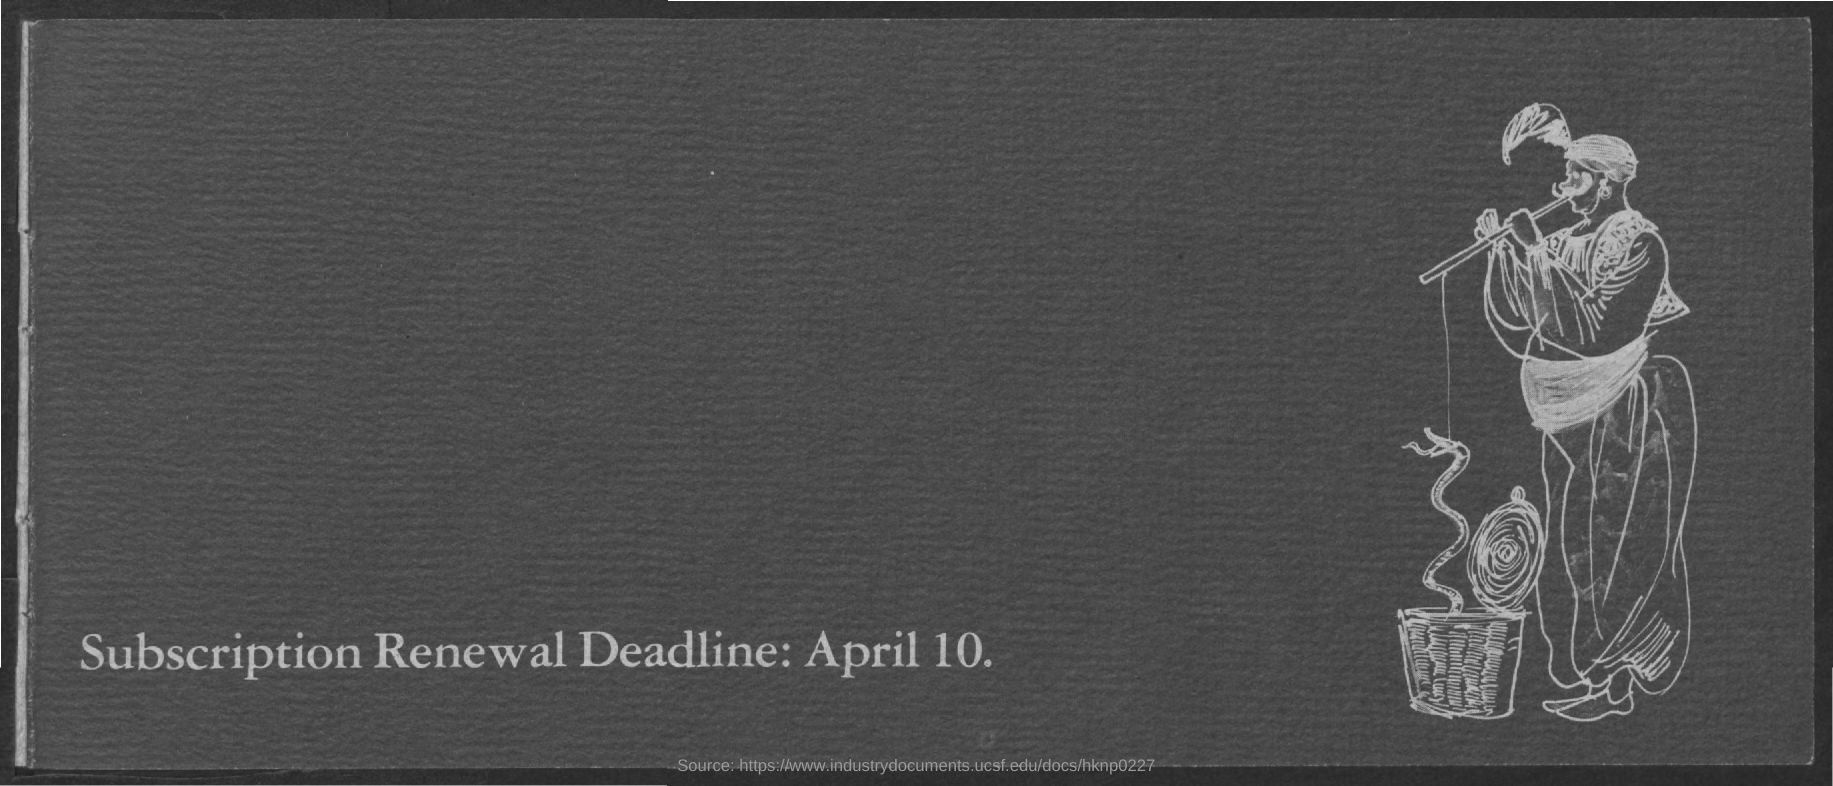What is the deadline for subscription renewal?
Provide a succinct answer. April 10. 